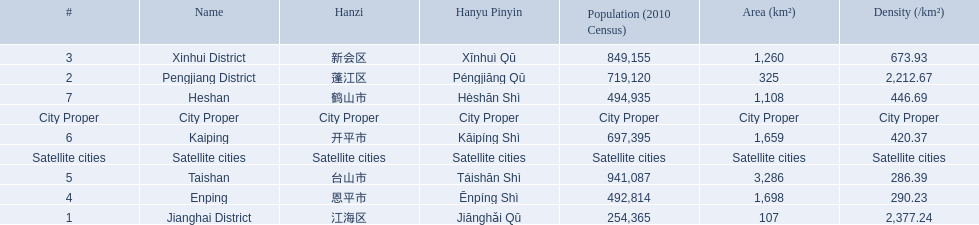What are all of the satellite cities? Enping, Taishan, Kaiping, Heshan. Of these, which has the highest population? Taishan. 